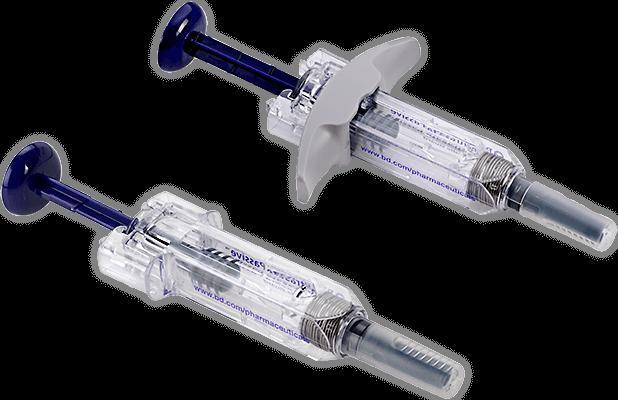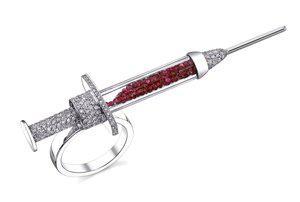The first image is the image on the left, the second image is the image on the right. Examine the images to the left and right. Is the description "A total of two syringes are shown." accurate? Answer yes or no. No. 